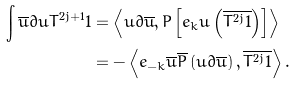<formula> <loc_0><loc_0><loc_500><loc_500>\int \overline { u } \partial u T ^ { 2 j + 1 } 1 & = \left \langle u \partial \overline { u } , P \left [ e _ { k } u \left ( \overline { T ^ { 2 j } 1 } \right ) \right ] \right \rangle \\ & = - \left \langle e _ { - k } \overline { u } \overline { P } \left ( u \partial \overline { u } \right ) , \overline { T ^ { 2 j } 1 } \right \rangle .</formula> 